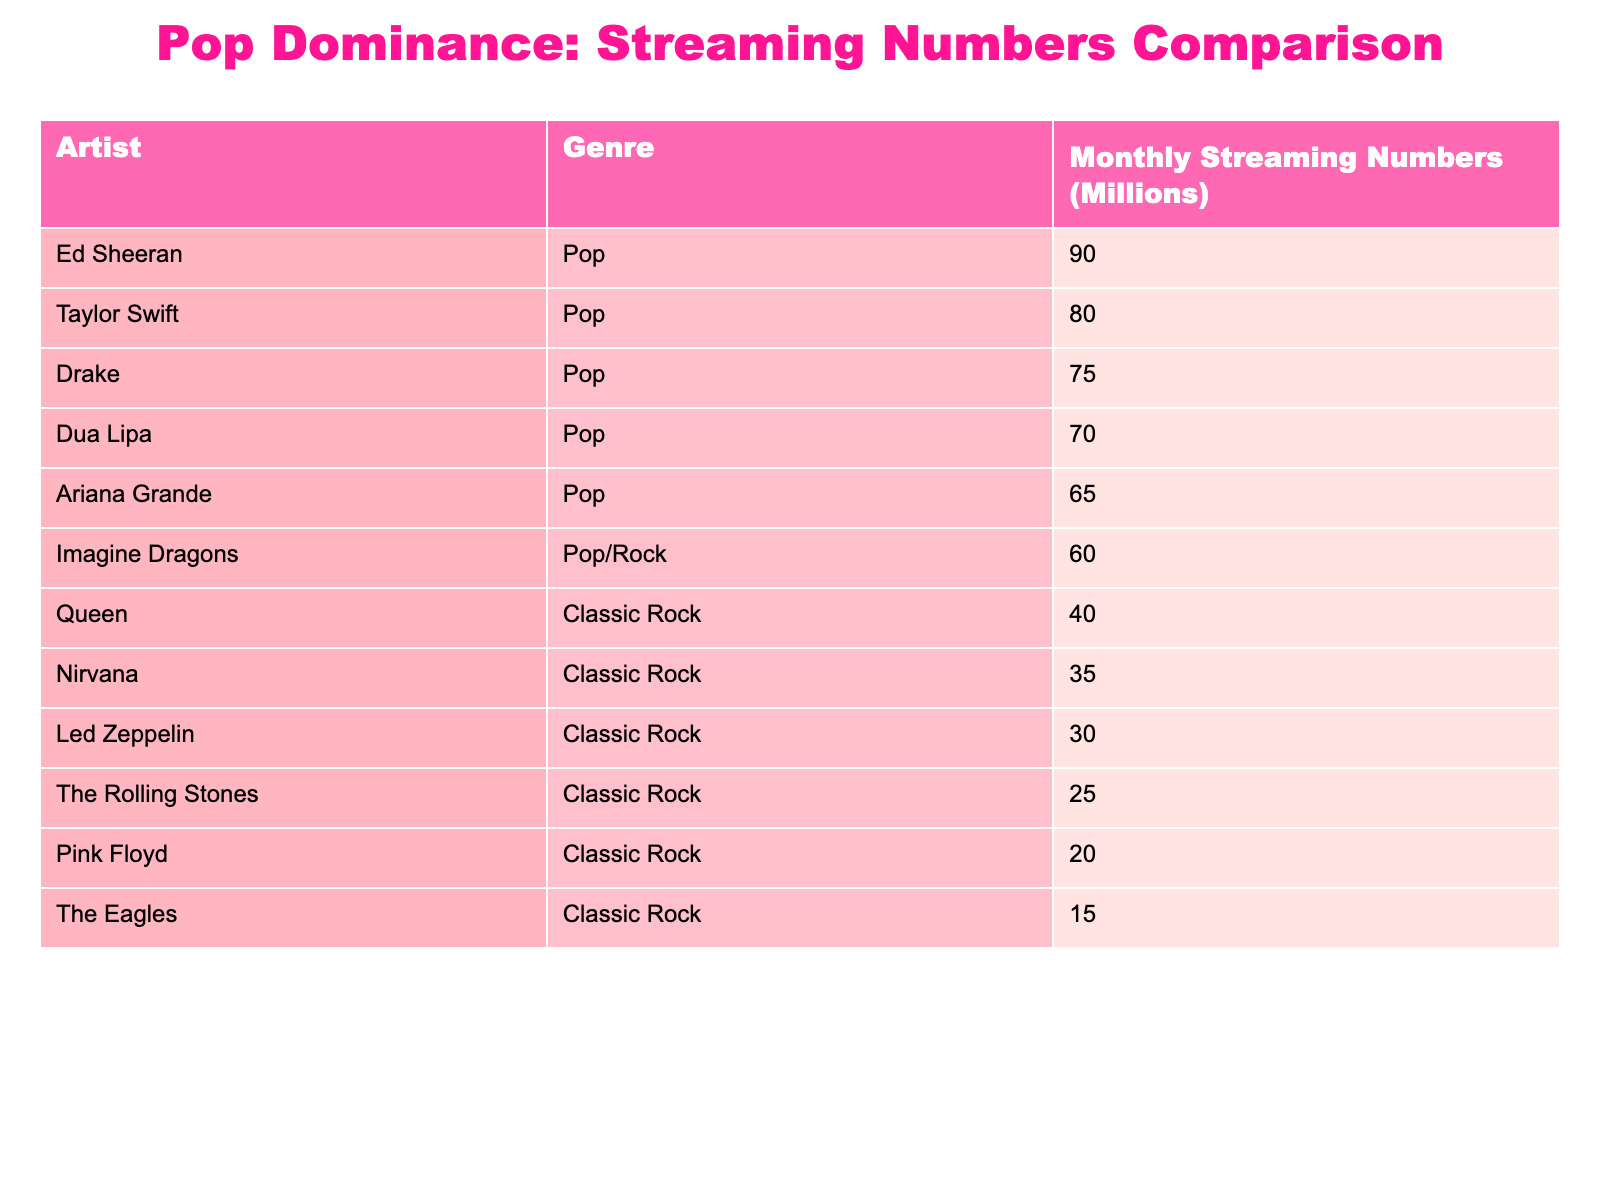What are the monthly streaming numbers for Ed Sheeran? From the table, Ed Sheeran is listed under the Pop genre, and his monthly streaming numbers are shown as 90 million.
Answer: 90 million Who has more monthly streams, Taylor Swift or Drake? The table shows that Taylor Swift has 80 million monthly streams, while Drake has 75 million. Thus, Taylor Swift has more monthly streams than Drake.
Answer: Taylor Swift How many monthly streams do the Classic Rock bands collectively have? Summing the monthly streams for all Classic Rock bands: Led Zeppelin (30) + The Rolling Stones (25) + Queen (40) + Pink Floyd (20) + The Eagles (15) + Nirvana (35) = 165 million.
Answer: 165 million Is Ariana Grande among the top three artists by monthly streaming numbers? By examining the monthly streaming numbers in the table, Ariana Grande with 65 million streams ranks below Ed Sheeran, Taylor Swift, and Drake, therefore she is not among the top three.
Answer: No Which Pop artist has the highest monthly streaming number, and how much is it? The data shows that Ed Sheeran has the highest monthly streaming number among the Pop artists at 90 million, as he is the only one above this figure.
Answer: Ed Sheeran, 90 million What is the difference in streaming numbers between Queen and The Eagles? The streaming numbers for Queen is 40 million while The Eagles have 15 million. The difference is calculated as 40 - 15 = 25 million.
Answer: 25 million Are there more Pop artists than Classic Rock bands in terms of monthly streaming numbers? There are four pure Pop artists (Taylor Swift, Drake, Dua Lipa, Ed Sheeran) and one hybrid artist (Imagine Dragons) in the Pop category. There are six Classic Rock bands. Since there are 5 Pop-related and 6 Classic Rock artists, the Pop artists are lesser in number.
Answer: No What is the average monthly streaming number for the Classic Rock bands? To find the average, we sum the monthly streams: Led Zeppelin (30) + The Rolling Stones (25) + Queen (40) + Pink Floyd (20) + The Eagles (15) + Nirvana (35) = 165 million. We then divide by 6 to get the average: 165 / 6 = 27.5 million.
Answer: 27.5 million 